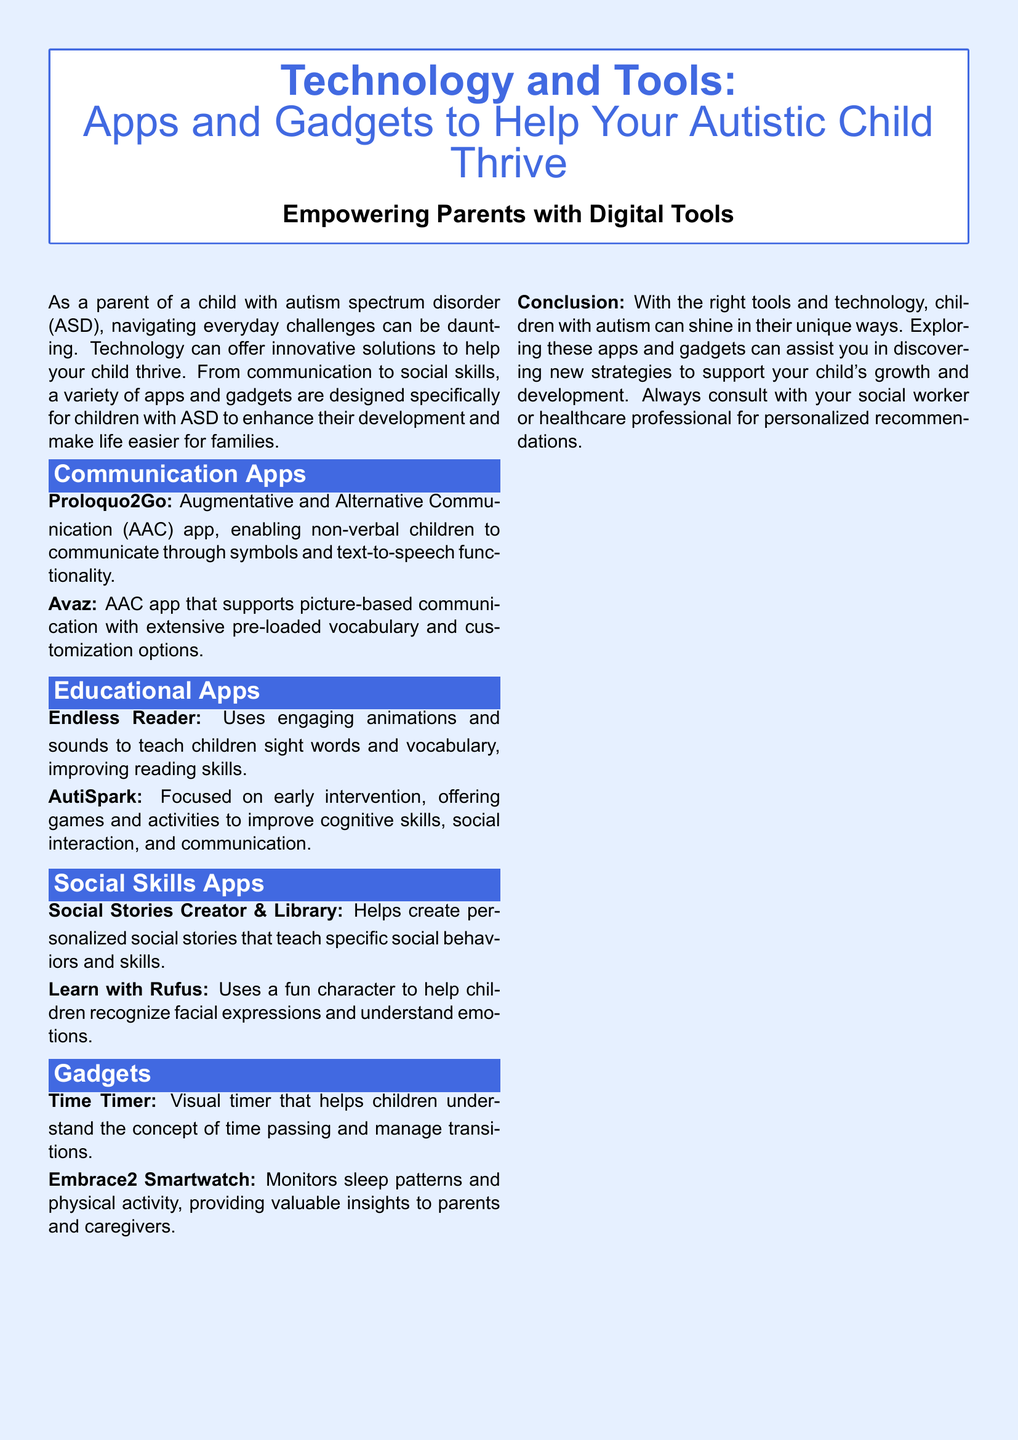What is the main topic of the document? The title clearly states the focus of the document is on technology and tools that support children with autism spectrum disorder.
Answer: Technology and Tools How many communication apps are mentioned? There are two communication apps listed in the section, Proloquo2Go and Avaz.
Answer: 2 What is the purpose of the Time Timer gadget? The document describes the Time Timer as a visual tool to help children understand time concepts and manage transitions.
Answer: Understand time What does the Embrace2 Smartwatch monitor? The description for Embrace2 indicates it tracks sleep patterns and physical activity.
Answer: Sleep patterns and physical activity Which app focuses on early intervention? Among the educational apps, AutiSpark is specifically mentioned for its focus on early intervention.
Answer: AutiSpark What type of app is Learn with Rufus? Learn with Rufus is categorized under social skills apps, aiding in recognizing emotions.
Answer: Social skills app Which section focuses on enhancing reading skills? The section on Educational Apps, specifically mentioning Endless Reader.
Answer: Educational Apps What color is used for the section titles? The section titles are in a highlight color specified in the document's formatting.
Answer: Highlight color 